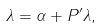<formula> <loc_0><loc_0><loc_500><loc_500>\lambda = \alpha + P ^ { \prime } \lambda ,</formula> 